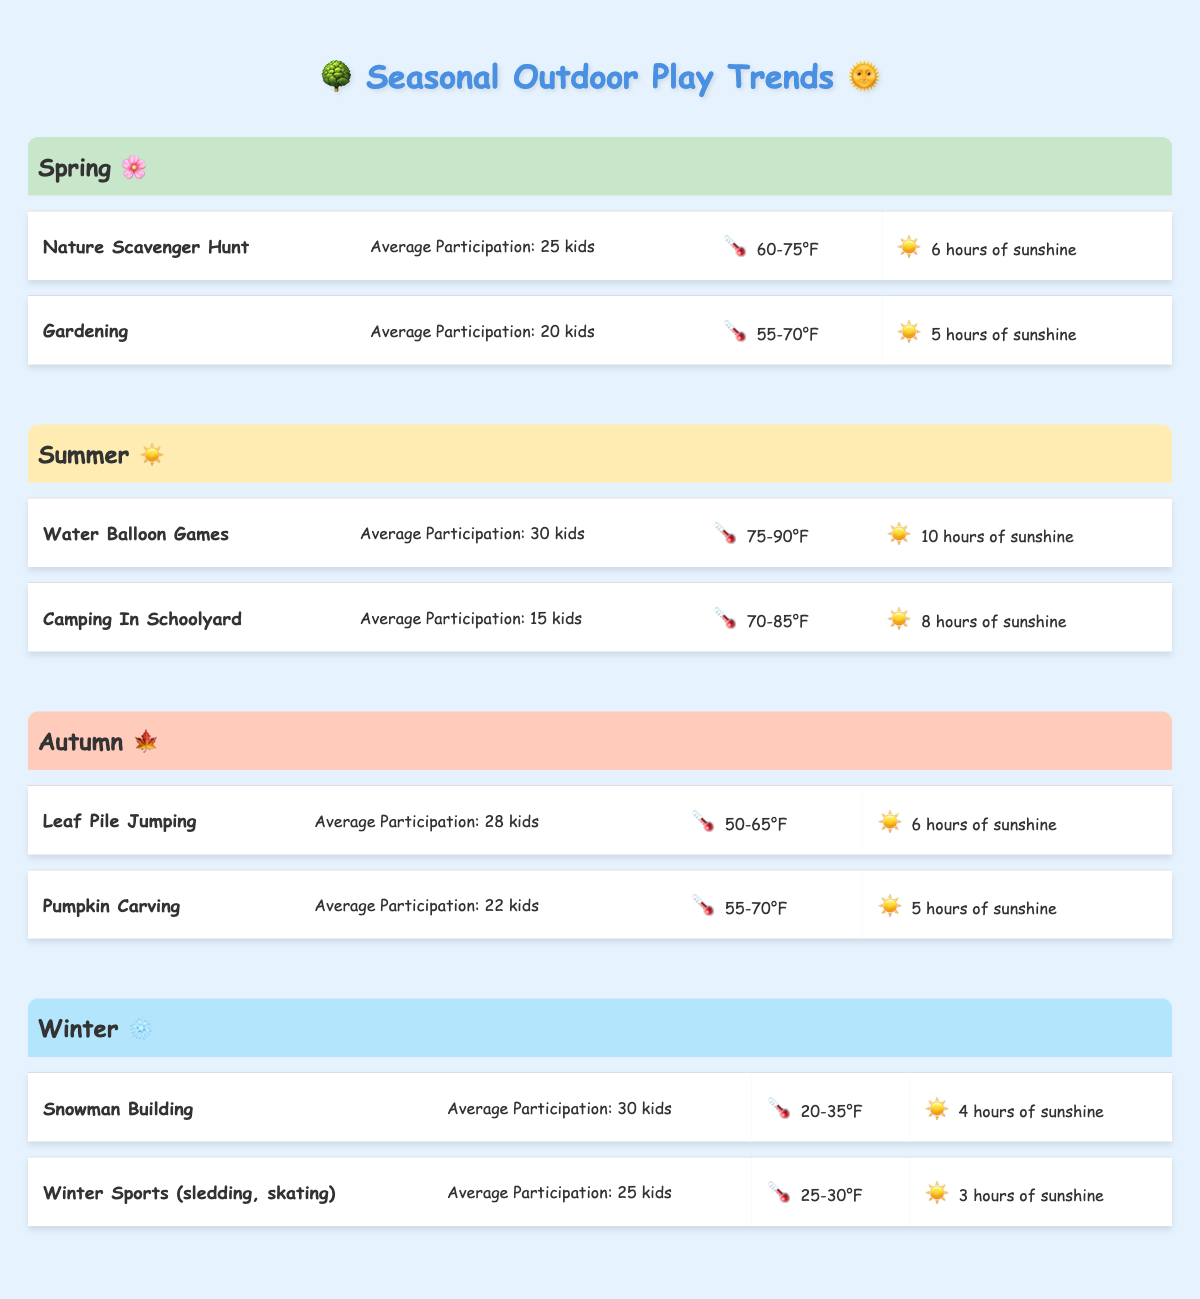What is the average participation in outdoor play activities in Spring? In Spring, there are two activities: Nature Scavenger Hunt with 25 participants and Gardening with 20 participants. To find the average, we add the numbers (25 + 20 = 45) and divide by the number of activities (2). Thus, 45/2 = 22.5.
Answer: 22.5 Which activity has the highest average participation in Summer? In Summer, there are two activities: Water Balloon Games with 30 participants and Camping in Schoolyard with 15 participants. Water Balloon Games has the higher number with 30 participants.
Answer: Water Balloon Games Is there a higher average participation in Autumn compared to Spring? Spring has an average participation of 22.5, while Autumn has two activities: Leaf Pile Jumping with 28 participants and Pumpkin Carving with 22. The Autumn average is (28 + 22) / 2 = 25. Since 25 is greater than 22.5, the average participation in Autumn is higher.
Answer: Yes What is the temperature range for Winter outdoor activities? There are two Winter activities: Snowman Building has a temperature range of 20-35°F, and Winter Sports has a range of 25-30°F. Since the activities both fall within these temperature ranges, we can summarize them for Winter as 20-35°F.
Answer: 20-35°F How many total kids participated in outdoor activities during Autumn? In Autumn, the total participation is Leaf Pile Jumping with 28 kids and Pumpkin Carving with 22 kids. Therefore, we add those two numbers (28 + 22 = 50) to find the total participation in Autumn.
Answer: 50 What is the average number of sunshine hours in Summer? The Summer activities have Water Balloon Games with 10 sunshine hours and Camping in Schoolyard with 8. We calculate the average by adding these numbers (10 + 8 = 18) and dividing by the number of activities (2), resulting in 18/2 = 9.
Answer: 9 Are there any outdoor activities in Spring that have a low likelihood of rain? In Spring, Gardening has a low likelihood of rain, while Nature Scavenger Hunt has a moderate likelihood. Thus, there is one activity (Gardening) with low rain likelihood.
Answer: Yes What is the average sunshine hours for Winter activities? For Winter, Snowman Building has 4 sunshine hours and Winter Sports has 3. To find the average, we add these (4 + 3 = 7) and divide by the number of activities (2), resulting in 7/2 = 3.5.
Answer: 3.5 Which season has the most outdoor participation on average? Participation averages are as follows: Spring (22.5), Summer (22.5), Autumn (25), Winter (27.5). To find the highest average, we can compare: Winter has the highest average of 27.5.
Answer: Winter 